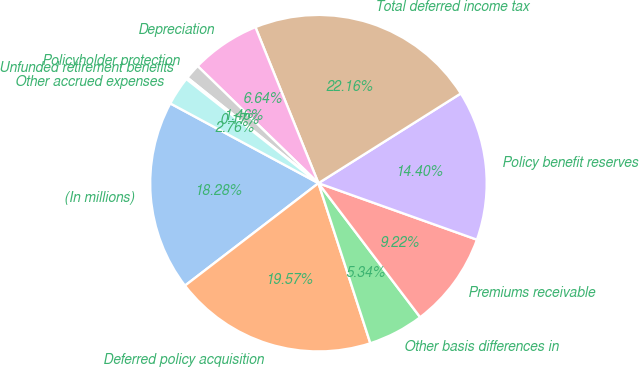Convert chart to OTSL. <chart><loc_0><loc_0><loc_500><loc_500><pie_chart><fcel>(In millions)<fcel>Deferred policy acquisition<fcel>Other basis differences in<fcel>Premiums receivable<fcel>Policy benefit reserves<fcel>Total deferred income tax<fcel>Depreciation<fcel>Policyholder protection<fcel>Unfunded retirement benefits<fcel>Other accrued expenses<nl><fcel>18.28%<fcel>19.57%<fcel>5.34%<fcel>9.22%<fcel>14.4%<fcel>22.16%<fcel>6.64%<fcel>1.46%<fcel>0.17%<fcel>2.76%<nl></chart> 